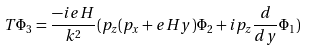Convert formula to latex. <formula><loc_0><loc_0><loc_500><loc_500>T \Phi _ { 3 } = \frac { - i e H } { k ^ { 2 } } ( p _ { z } ( p _ { x } + e H y ) \Phi _ { 2 } + i p _ { z } \frac { d } { d y } \Phi _ { 1 } )</formula> 